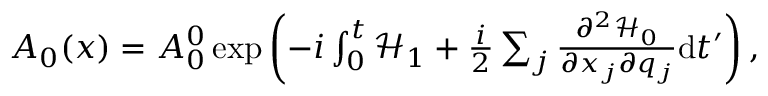Convert formula to latex. <formula><loc_0><loc_0><loc_500><loc_500>\begin{array} { r } { A _ { 0 } ( x ) = A _ { 0 } ^ { 0 } \exp \left ( - i \int _ { 0 } ^ { t } \mathcal { H } _ { 1 } + \frac { i } { 2 } \sum _ { j } \frac { \partial ^ { 2 } \mathcal { H } _ { 0 } } { \partial x _ { j } \partial q _ { j } } d t ^ { \prime } \right ) , } \end{array}</formula> 